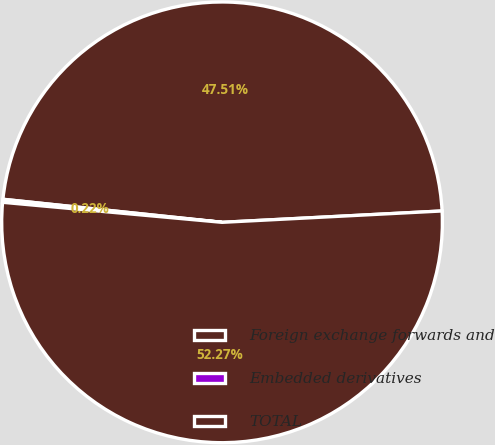Convert chart to OTSL. <chart><loc_0><loc_0><loc_500><loc_500><pie_chart><fcel>Foreign exchange forwards and<fcel>Embedded derivatives<fcel>TOTAL<nl><fcel>47.51%<fcel>0.22%<fcel>52.27%<nl></chart> 